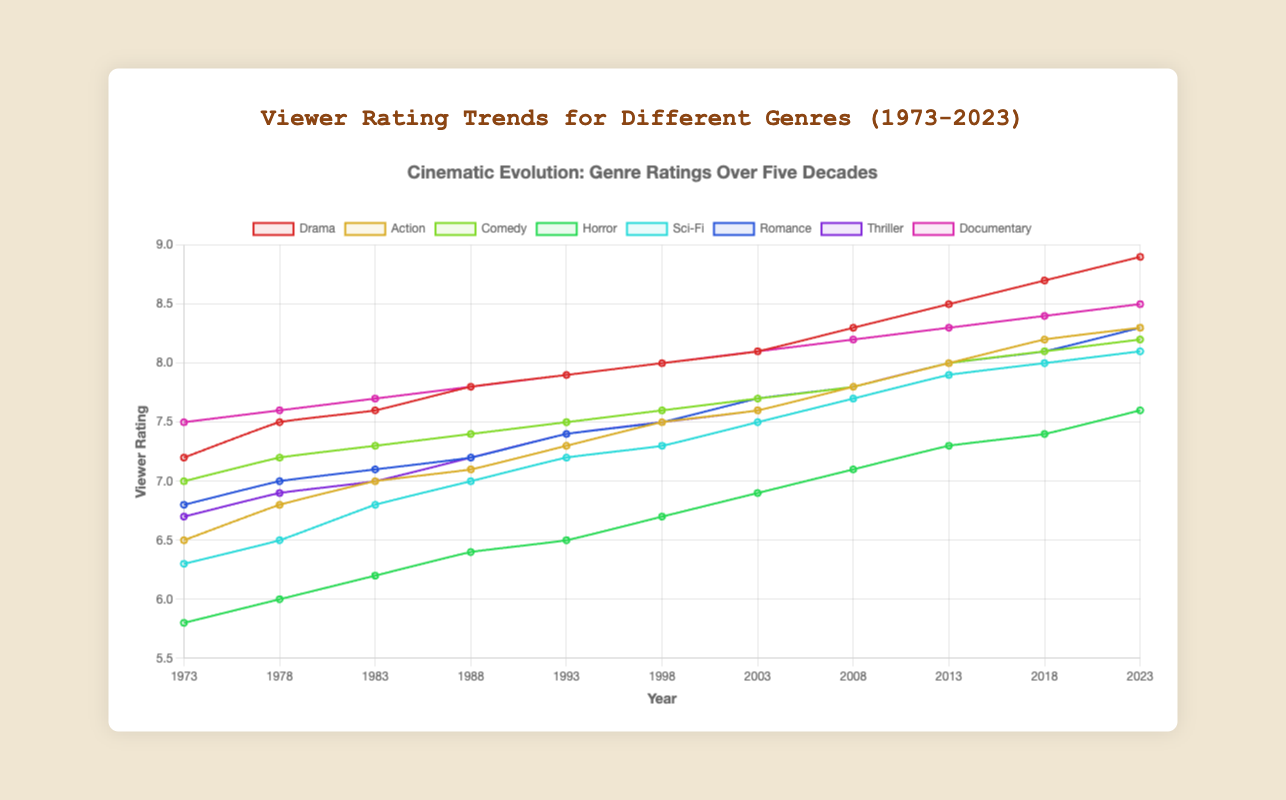What's the trend of the viewer rating for the Drama genre from 1973 to 2023? The viewer rating for the Drama genre shows a consistent upward trend from 7.2 in 1973 to 8.9 in 2023.
Answer: Consistent upward trend Which genre had the highest viewer rating in 2023? In 2023, the Drama genre had the highest viewer rating of 8.9.
Answer: Drama What is the average viewer rating for the Horror genre in the years 1973 and 2023? The viewer rating for Horror in 1973 is 5.8 and in 2023 is 7.6. The average is (5.8 + 7.6) / 2 = 6.7.
Answer: 6.7 Compare the viewer ratings of the Sci-Fi genre and the Action genre in 1998. Which is higher? In 1998, the viewer rating for Sci-Fi is 7.3 while the Action genre is 7.5. The Action genre has the higher rating.
Answer: Action What is the difference in viewer rating between the Documentary genre in 1973 and 2023? The viewer rating for Documentaries in 1973 is 7.5 and in 2023 is 8.5. The difference is 8.5 - 7.5 = 1.0.
Answer: 1.0 Which genre had a higher viewer rating in 2018, Comedy or Romance? In 2018, the viewer rating for Comedy is 8.1 and for Romance is 8.1. Both genres had the same rating.
Answer: Equal Identify the genre that had the lowest viewer rating in 1988 and state its value. In 1988, the Horror genre had the lowest viewer rating at 6.4.
Answer: Horror, 6.4 How does the viewer rating for the Romance genre change from 2003 to 2023? The viewer rating for the Romance genre increased from 7.7 in 2003 to 8.3 in 2023.
Answer: Increase What is the trend in viewer ratings for the Documentary genre over the entire period? The viewer rating for the Documentary genre steadily increased from 7.5 in 1973 to 8.5 in 2023.
Answer: Steadily increased Compare the viewer ratings of the Drama and Action genres in 2013. Which one had a higher rating? In 2013, the Drama genre had a viewer rating of 8.5, while the Action genre had a rating of 8.0. Drama had the higher rating.
Answer: Drama 